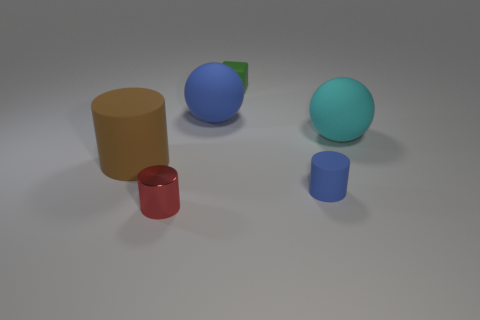Subtract all rubber cylinders. How many cylinders are left? 1 Subtract all red cylinders. How many cylinders are left? 2 Subtract 1 spheres. How many spheres are left? 1 Subtract all balls. How many objects are left? 4 Subtract all cyan blocks. Subtract all cyan cylinders. How many blocks are left? 1 Subtract all cyan spheres. How many red cylinders are left? 1 Subtract all large cyan objects. Subtract all tiny metal objects. How many objects are left? 4 Add 4 cyan spheres. How many cyan spheres are left? 5 Add 2 big green cubes. How many big green cubes exist? 2 Add 1 large blue balls. How many objects exist? 7 